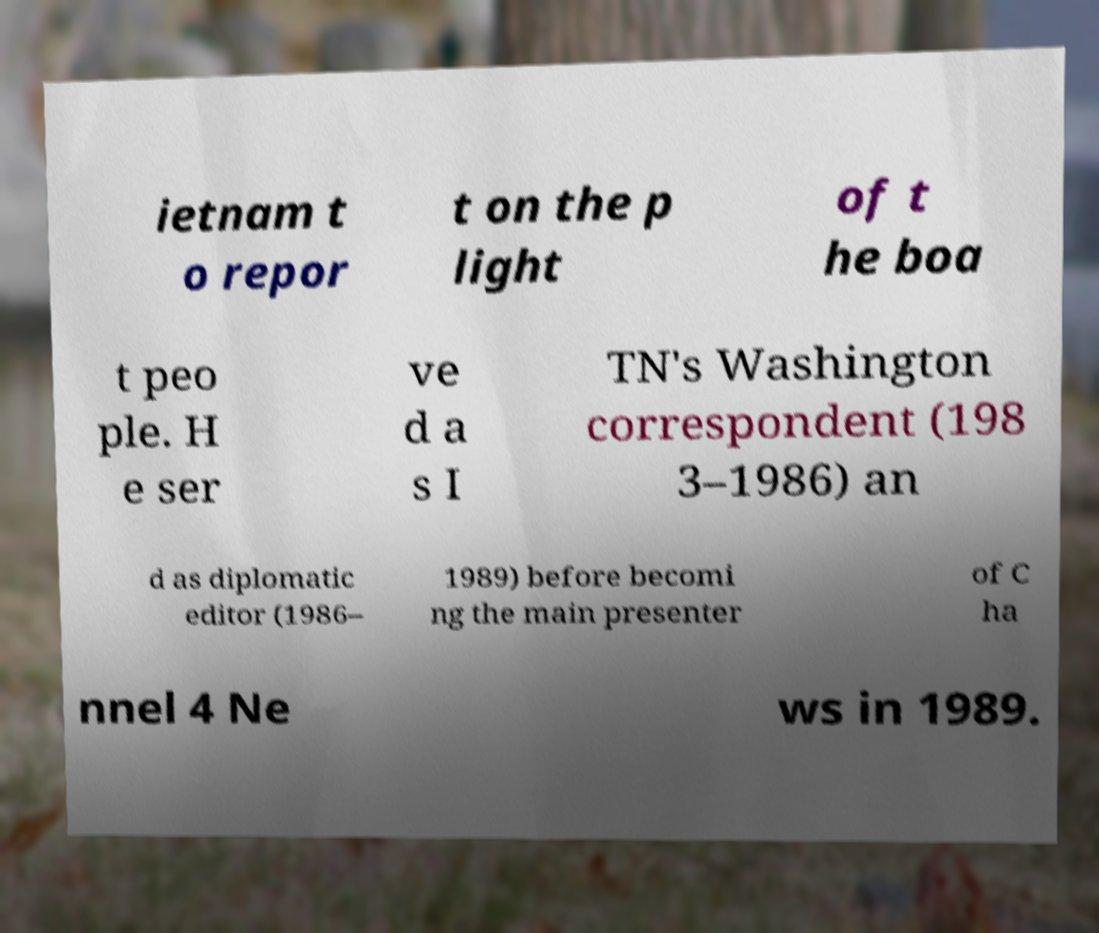Please read and relay the text visible in this image. What does it say? ietnam t o repor t on the p light of t he boa t peo ple. H e ser ve d a s I TN's Washington correspondent (198 3–1986) an d as diplomatic editor (1986– 1989) before becomi ng the main presenter of C ha nnel 4 Ne ws in 1989. 